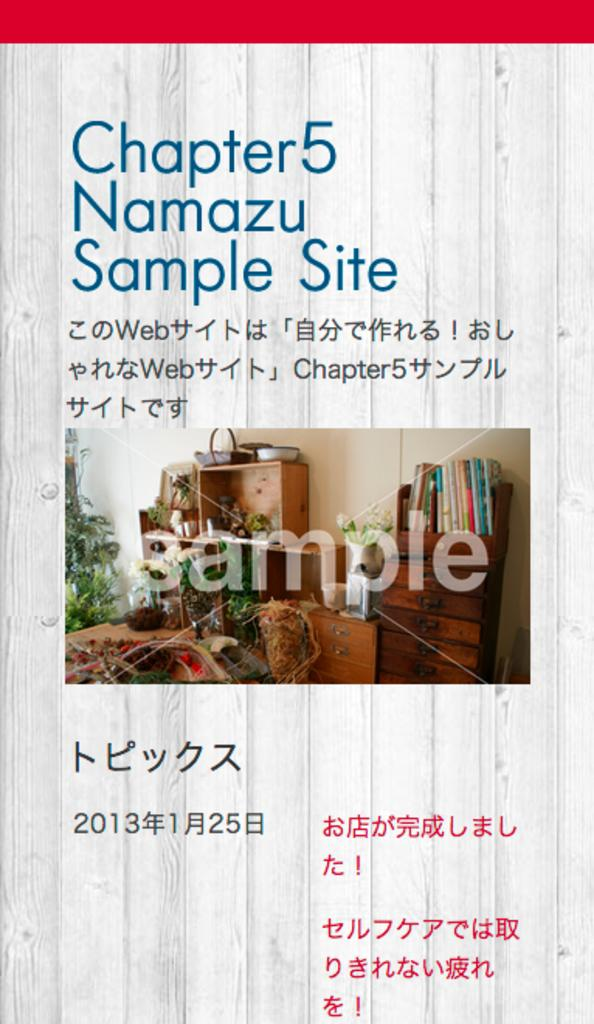Provide a one-sentence caption for the provided image. A book called Namazu Sample site shows samples of images. 